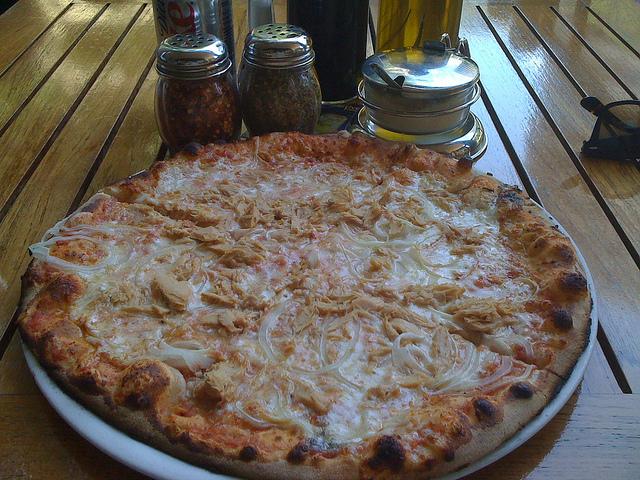Is that a plain pizza?
Write a very short answer. No. What food is this?
Write a very short answer. Pizza. What condiments are on the table?
Short answer required. Mayonnaise. 